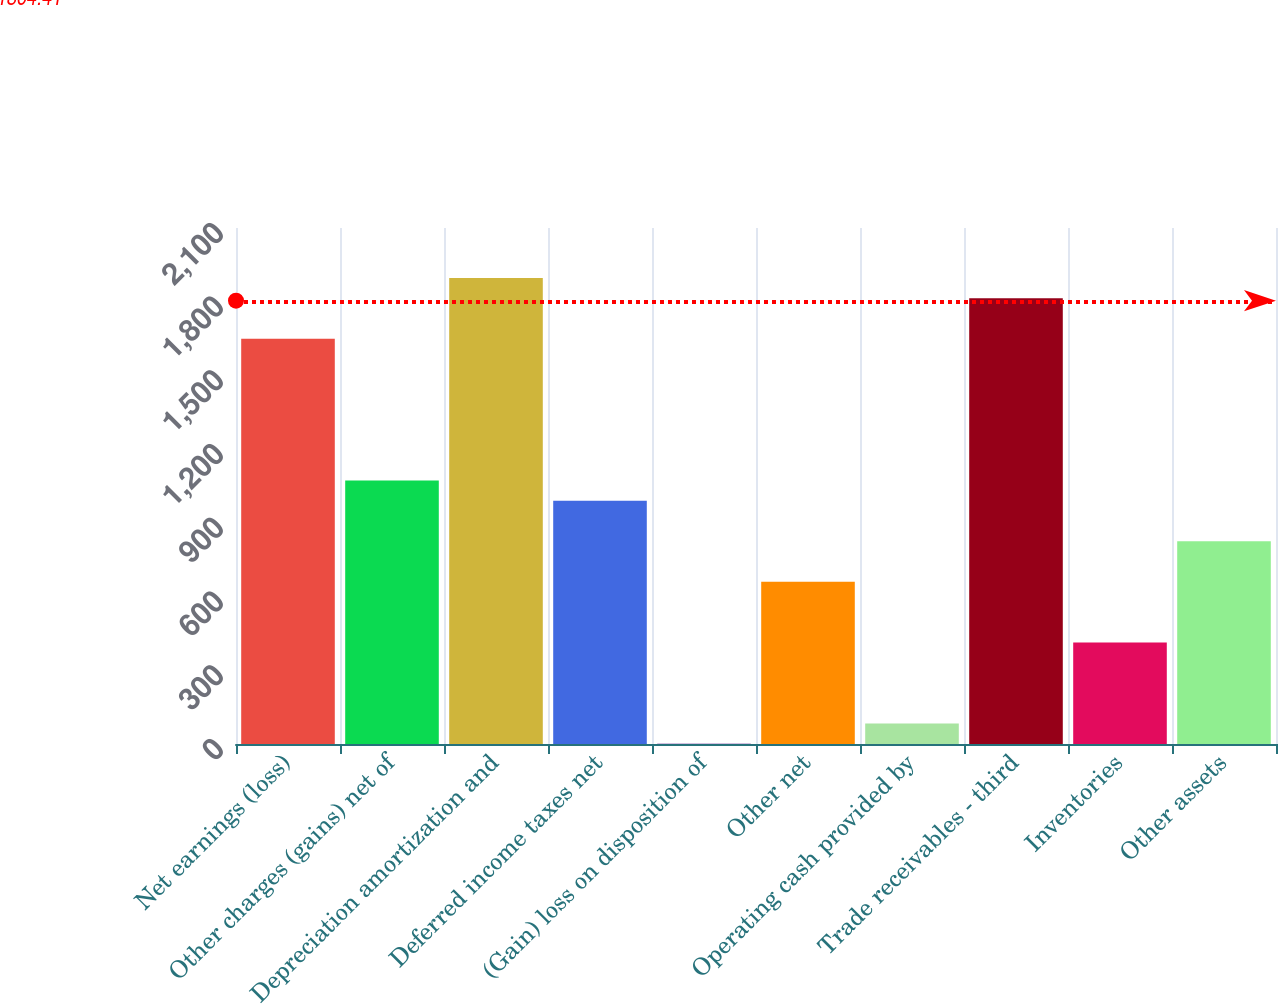Convert chart to OTSL. <chart><loc_0><loc_0><loc_500><loc_500><bar_chart><fcel>Net earnings (loss)<fcel>Other charges (gains) net of<fcel>Depreciation amortization and<fcel>Deferred income taxes net<fcel>(Gain) loss on disposition of<fcel>Other net<fcel>Operating cash provided by<fcel>Trade receivables - third<fcel>Inventories<fcel>Other assets<nl><fcel>1649<fcel>1072.2<fcel>1896.2<fcel>989.8<fcel>1<fcel>660.2<fcel>83.4<fcel>1813.8<fcel>413<fcel>825<nl></chart> 